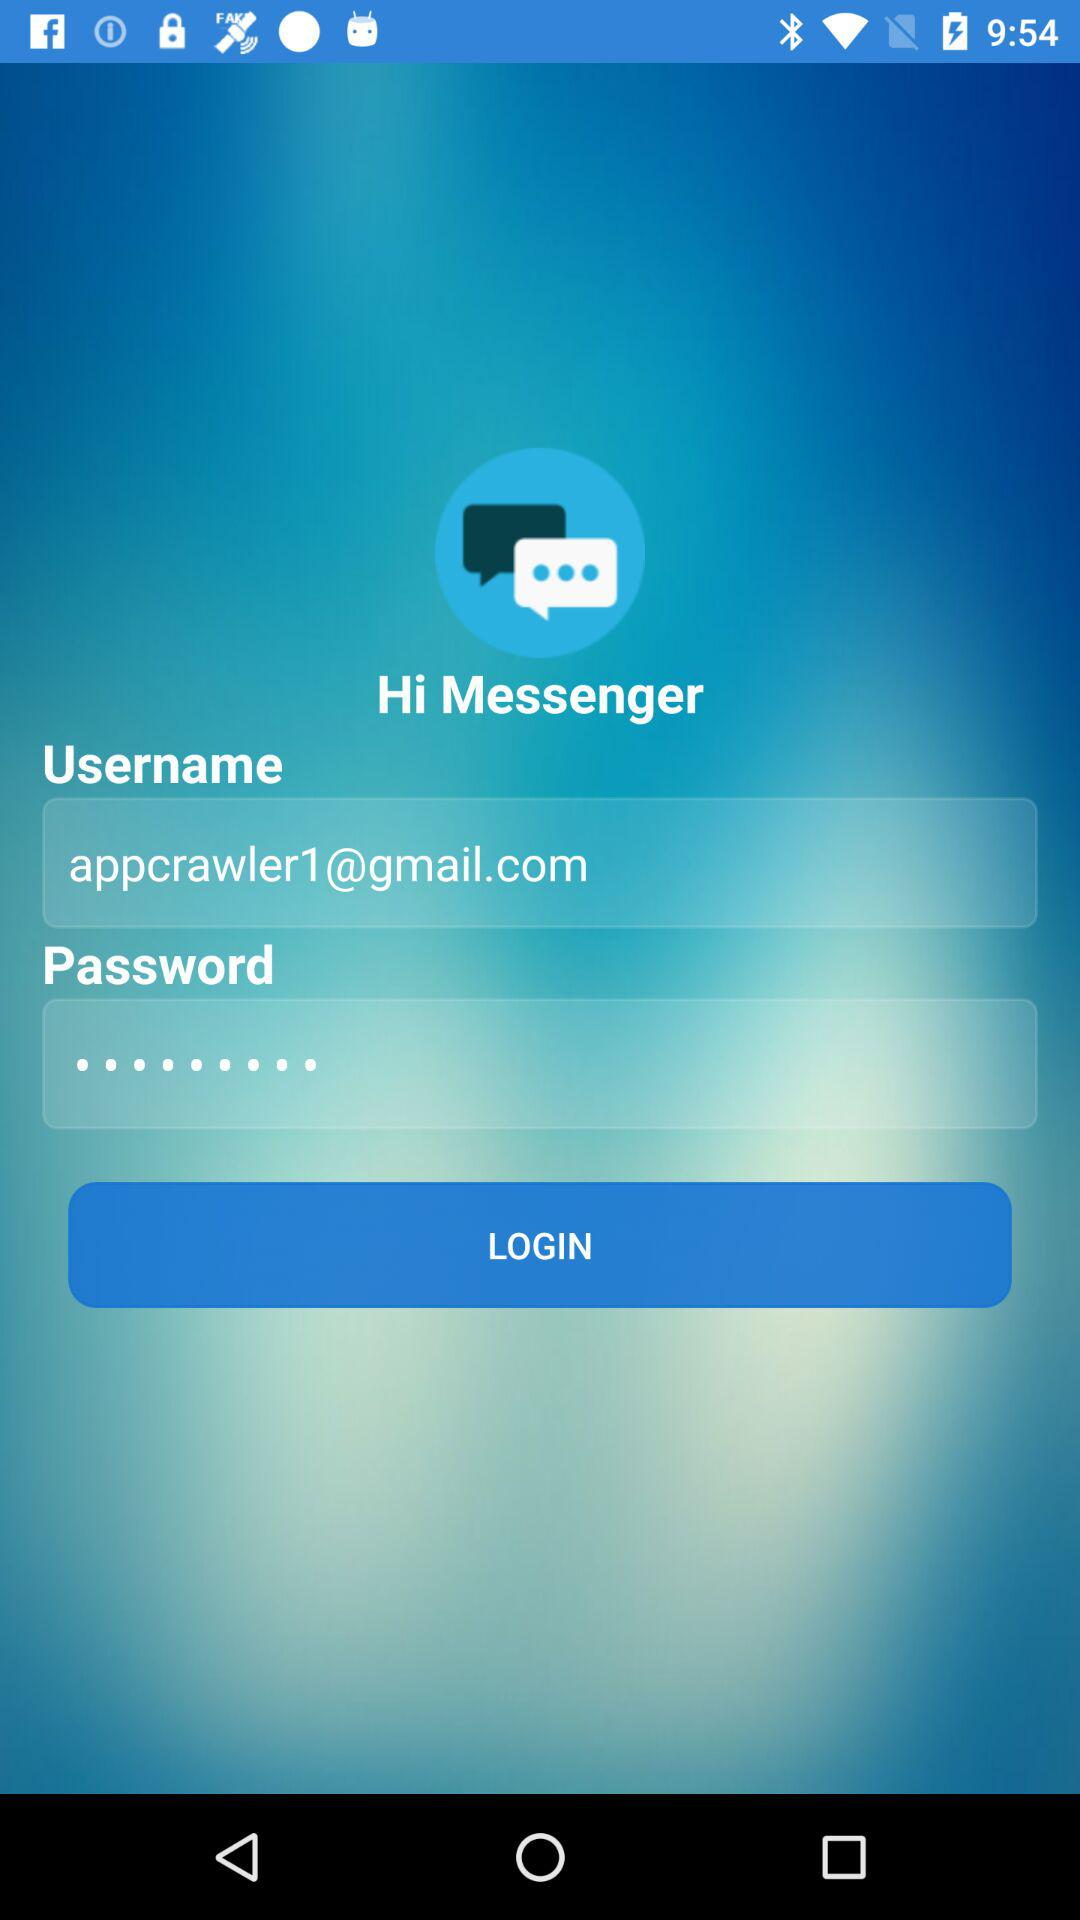What is the given email address? The given email address is appcrawler1@gmail.com. 